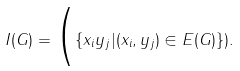Convert formula to latex. <formula><loc_0><loc_0><loc_500><loc_500>I ( G ) = \Big ( \{ x _ { i } y _ { j } | ( x _ { i } , y _ { j } ) \in E ( G ) \} ) .</formula> 